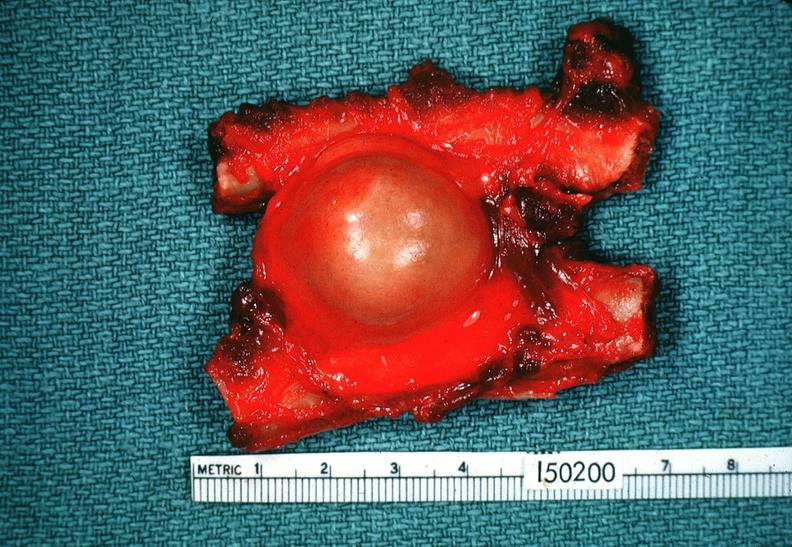what is present?
Answer the question using a single word or phrase. Nervous 